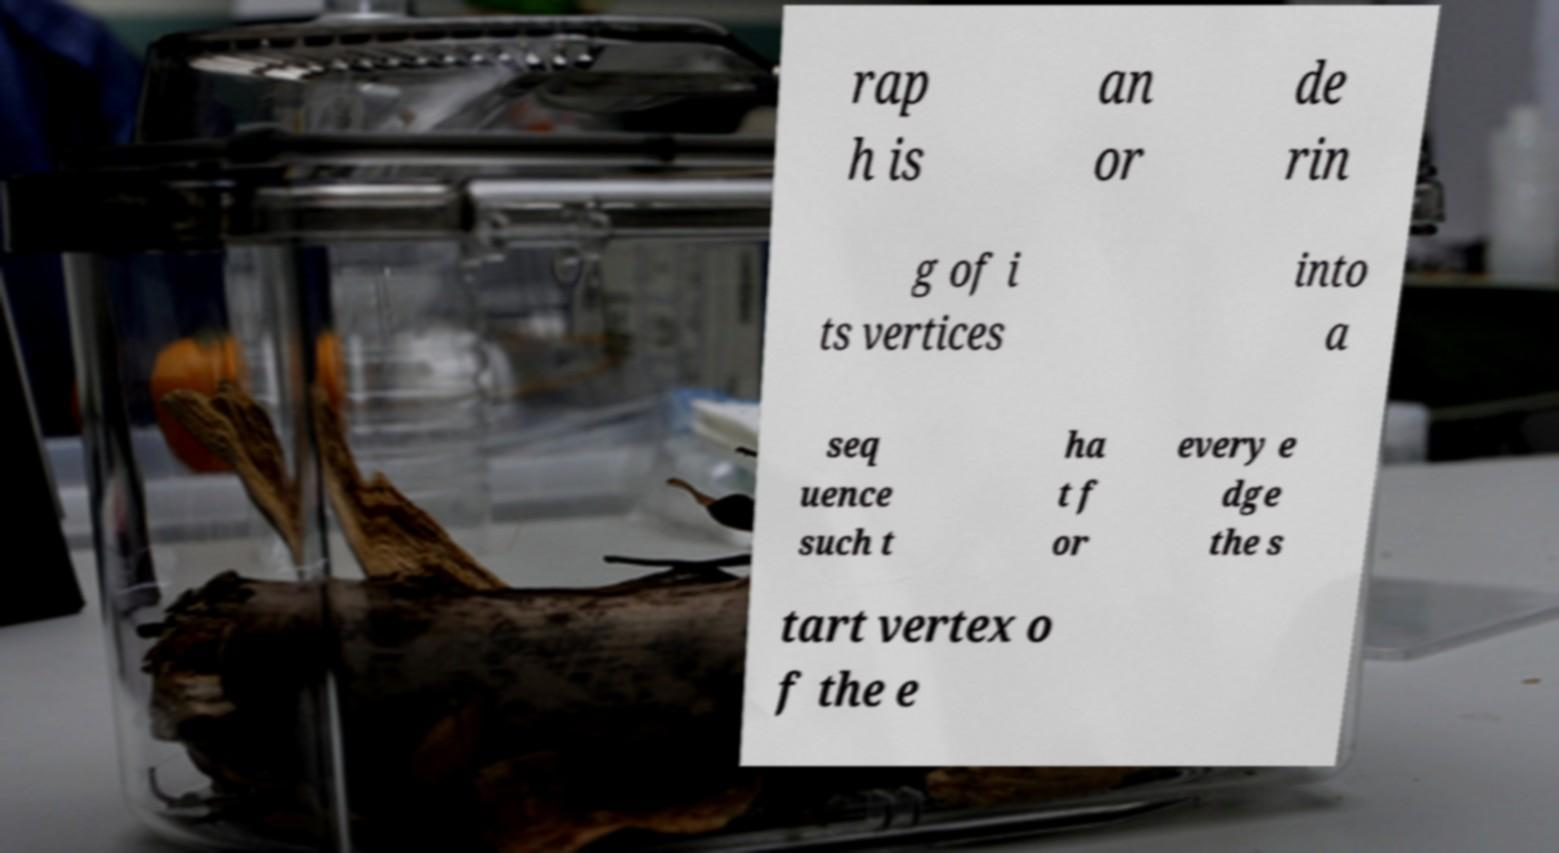Please identify and transcribe the text found in this image. rap h is an or de rin g of i ts vertices into a seq uence such t ha t f or every e dge the s tart vertex o f the e 